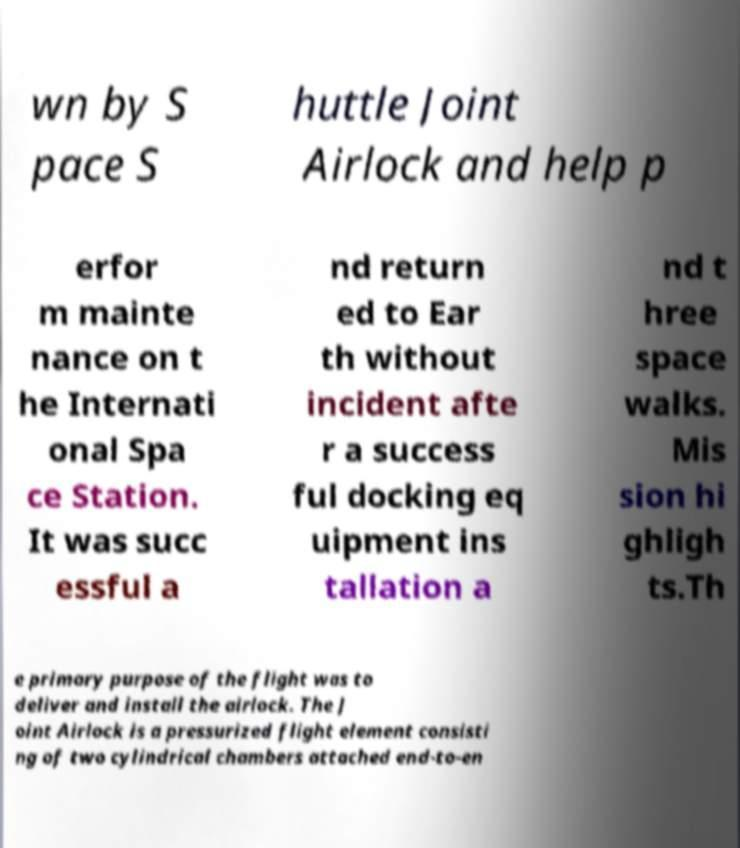Please read and relay the text visible in this image. What does it say? wn by S pace S huttle Joint Airlock and help p erfor m mainte nance on t he Internati onal Spa ce Station. It was succ essful a nd return ed to Ear th without incident afte r a success ful docking eq uipment ins tallation a nd t hree space walks. Mis sion hi ghligh ts.Th e primary purpose of the flight was to deliver and install the airlock. The J oint Airlock is a pressurized flight element consisti ng of two cylindrical chambers attached end-to-en 